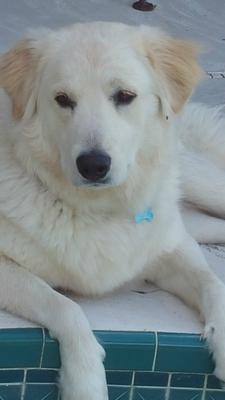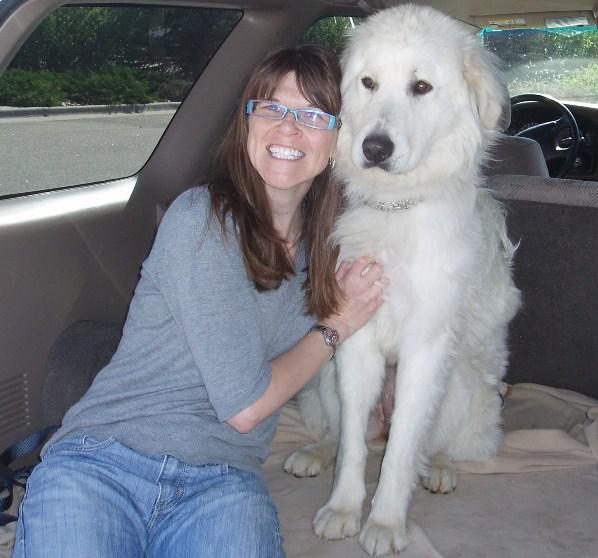The first image is the image on the left, the second image is the image on the right. Examine the images to the left and right. Is the description "An image includes a person wearing jeans inside a vehicle with one white dog." accurate? Answer yes or no. Yes. The first image is the image on the left, the second image is the image on the right. Considering the images on both sides, is "The dog in the image on the right is with a human in a vehicle." valid? Answer yes or no. Yes. 